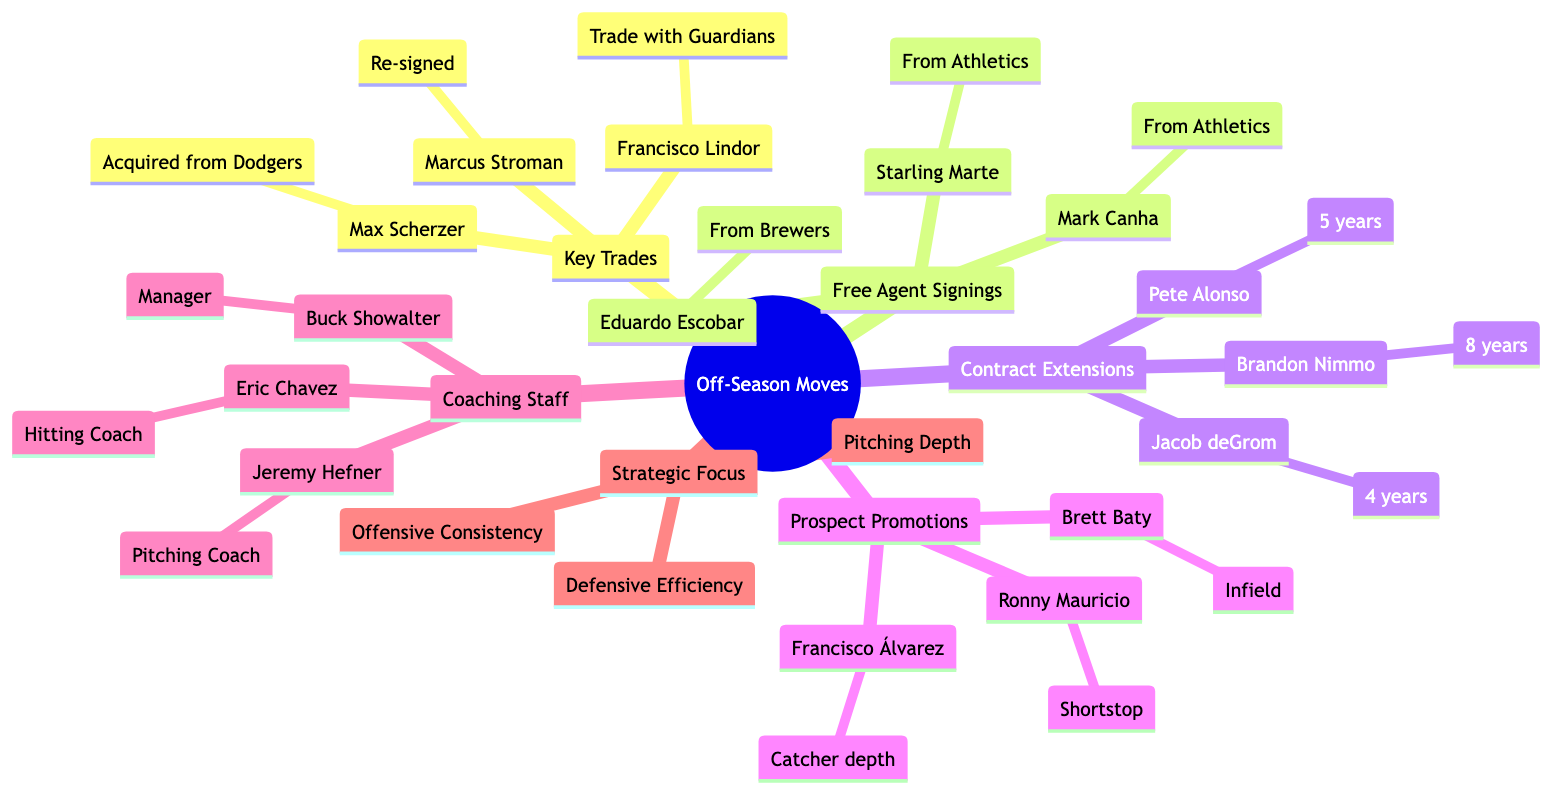What player was acquired from the Los Angeles Dodgers? The diagram indicates that Max Scherzer was acquired from the Los Angeles Dodgers, with this detailed relationship under the "Key Trades" section.
Answer: Max Scherzer How many years is Brandon Nimmo's contract extension? The diagram shows that Brandon Nimmo's contract extension is for 8 years, directly listed under the "Contract Extensions" category.
Answer: 8 years What is the primary focus under Strategic Focus? The most prominent category listed under "Strategic Focus" includes several elements, but "Pitching Depth" is the first item mentioned, indicating a critical focus for the team.
Answer: Pitching Depth Which hitting coach was appointed? In the "Coaching Staff Changes" section, Eric Chavez is specifically mentioned as the newly appointed hitting coach.
Answer: Eric Chavez How many players were signed from the Oakland Athletics? The diagram includes two players, Starling Marte and Mark Canha, both listed under "Free Agent Signings" as signed from the Oakland Athletics, indicating two total.
Answer: 2 What position is Francisco Álvarez promoted for? In the "Prospect Promotions" section, Francisco Álvarez is mentioned to be promoted for catcher depth, directly outlining his role and purpose for the promotion.
Answer: Catcher depth What is the total number of key trades listed? The diagram categorizes three players under "Key Trades": Max Scherzer, Francisco Lindor, and Marcus Stroman, indicating a total of three trades.
Answer: 3 Who retained the role of pitching coach? The diagram specifically names Jeremy Hefner as the retained pitching coach within the "Coaching Staff Changes," defining his role in the new setup.
Answer: Jeremy Hefner Which player is likely to debut as shortstop? Under "Prospect Promotions," the diagram states that Ronny Mauricio is likely to debut as shortstop, explicitly outlining his anticipated role.
Answer: Ronny Mauricio 